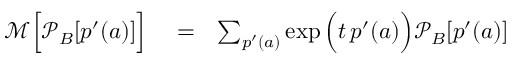Convert formula to latex. <formula><loc_0><loc_0><loc_500><loc_500>\begin{array} { r l r } { \mathcal { M } \left [ \mathcal { P } _ { B } [ p ^ { \prime } ( a ) ] \right ] } & = } & { \sum _ { p ^ { \prime } ( a ) } \exp \left ( t \, p ^ { \prime } ( a ) \right ) \mathcal { P } _ { B } [ p ^ { \prime } ( a ) ] } \end{array}</formula> 